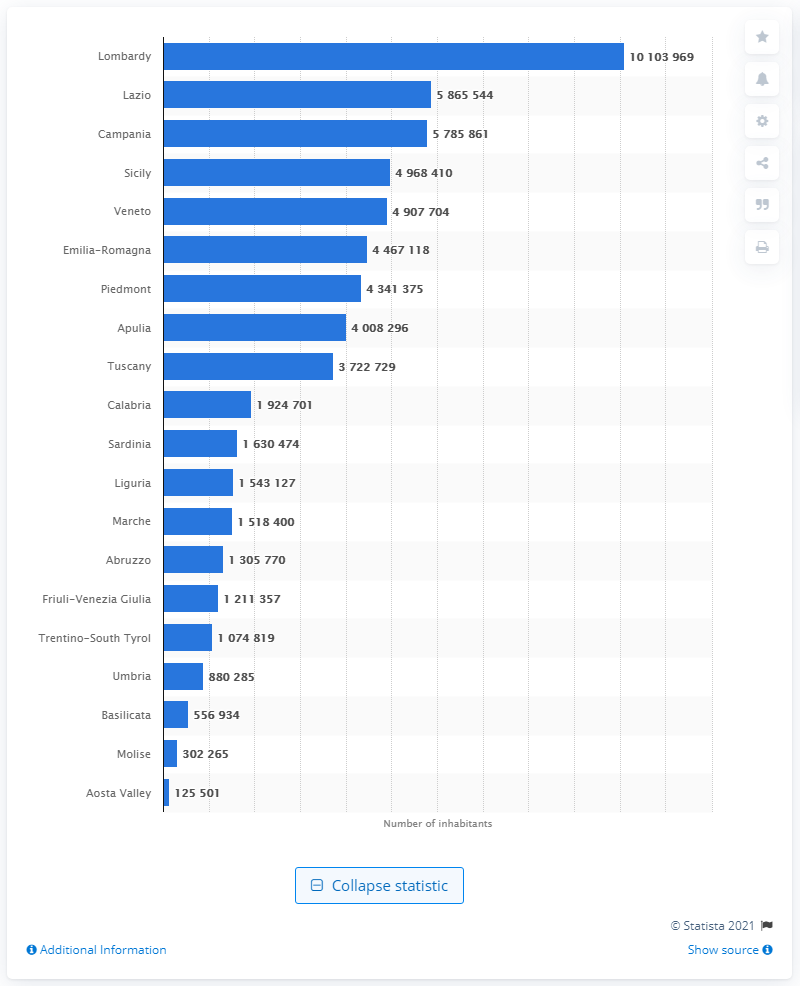Outline some significant characteristics in this image. Lombardy is the most populous region in Italy. 